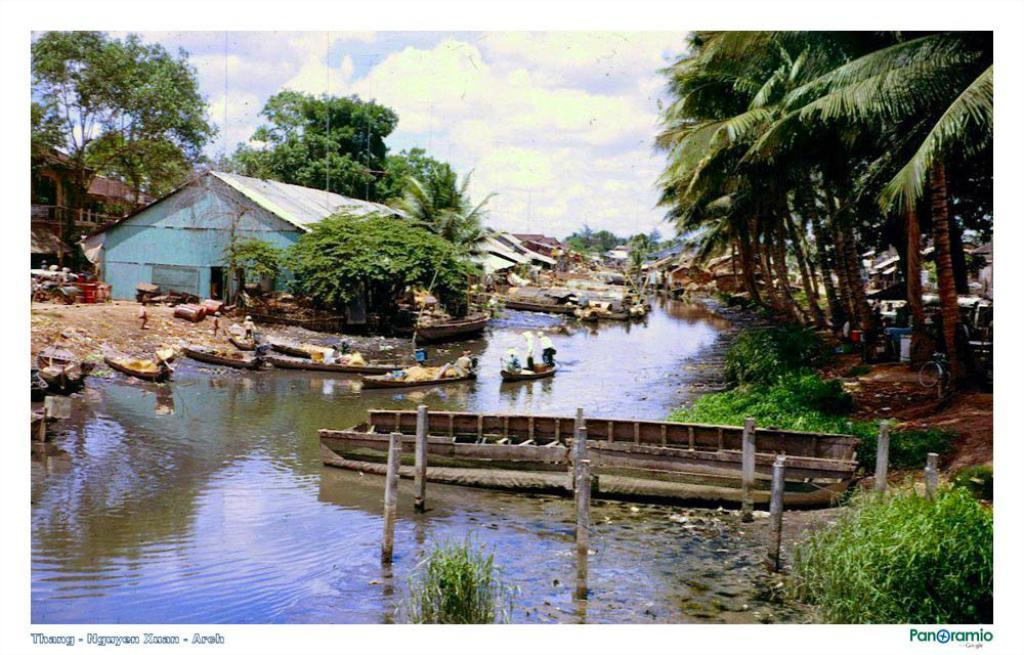What is the main subject of the image? The image contains a picture. What are the persons in the image doing? The persons are standing in boats in the picture. What type of structures can be seen in the image? There are sheds, huts, and bridges in the picture. What type of vegetation is present in the image? There are trees in the picture. What type of pathway is visible in the image? There is a walkway in the picture. What type of poles are present in the image? There are poles in the picture. What type of water body is present in the image? There is a canal in the picture. What is visible in the sky in the image? The sky is visible in the picture, and clouds are present. How does the power of the boats increase in the image? There is no indication of the boats' power or speed in the image, so it cannot be determined from the picture. 